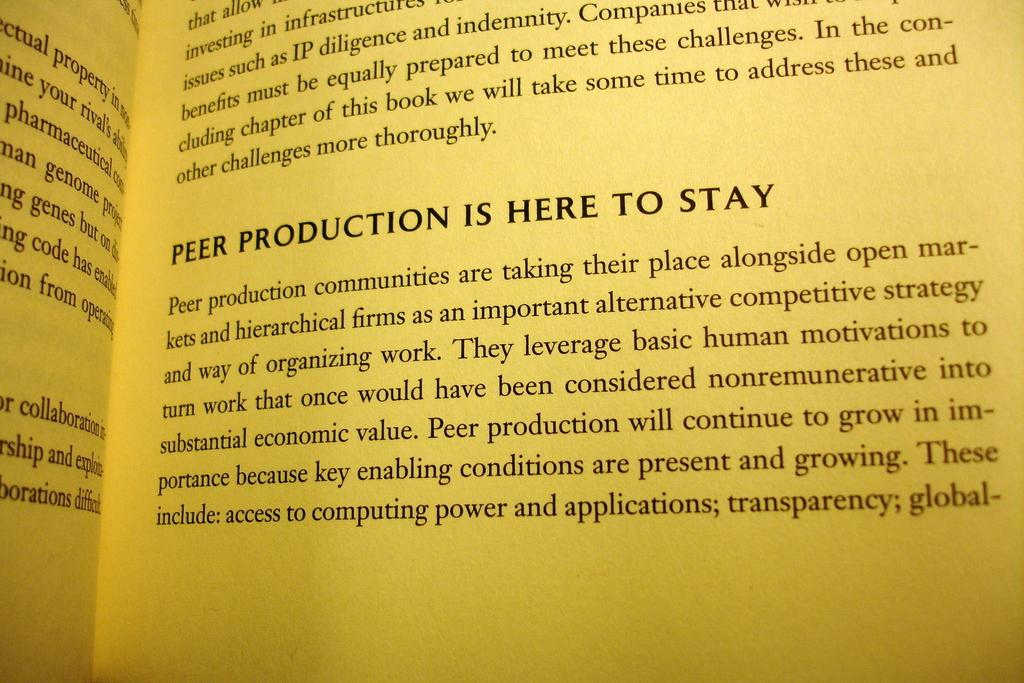Provide a one-sentence caption for the provided image. A book is opened to a page talking about peer production. 